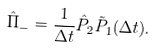Convert formula to latex. <formula><loc_0><loc_0><loc_500><loc_500>\hat { \Pi } _ { - } = \frac { 1 } { \Delta t } \hat { P } _ { 2 } \tilde { P } _ { 1 } ( \Delta t ) .</formula> 